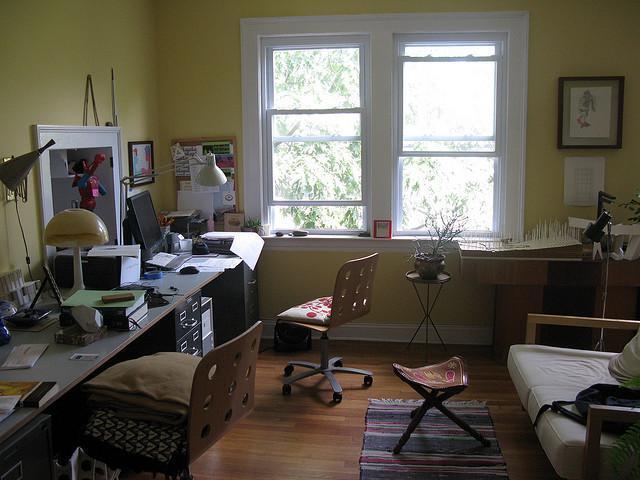How many chairs are in the photo?
Give a very brief answer. 3. 